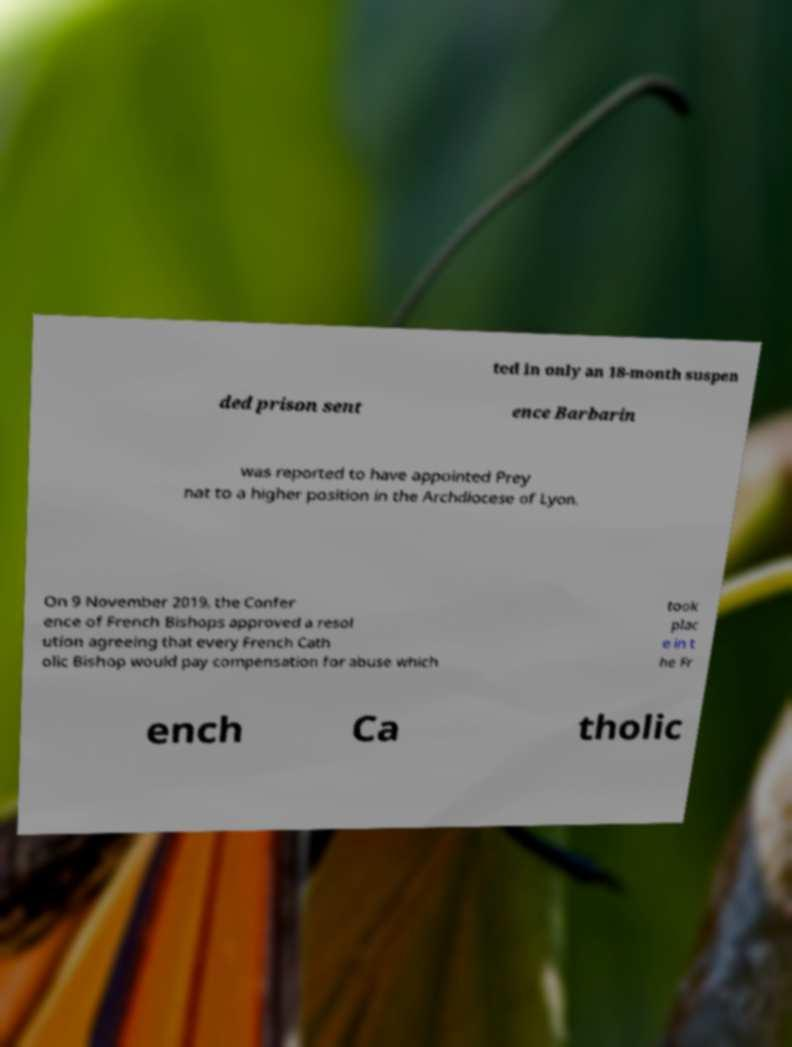I need the written content from this picture converted into text. Can you do that? ted in only an 18-month suspen ded prison sent ence Barbarin was reported to have appointed Prey nat to a higher position in the Archdiocese of Lyon. On 9 November 2019, the Confer ence of French Bishops approved a resol ution agreeing that every French Cath olic Bishop would pay compensation for abuse which took plac e in t he Fr ench Ca tholic 